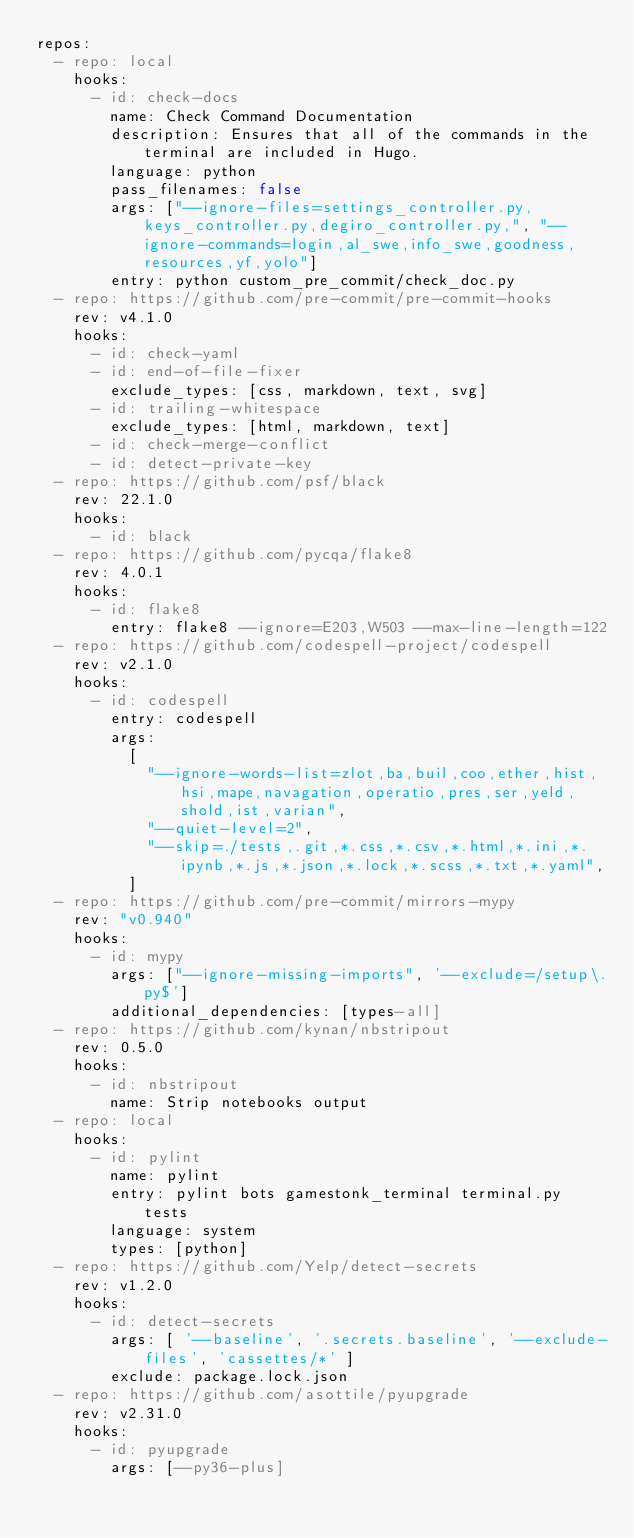<code> <loc_0><loc_0><loc_500><loc_500><_YAML_>repos:
  - repo: local
    hooks:
      - id: check-docs
        name: Check Command Documentation
        description: Ensures that all of the commands in the terminal are included in Hugo.
        language: python
        pass_filenames: false
        args: ["--ignore-files=settings_controller.py,keys_controller.py,degiro_controller.py,", "--ignore-commands=login,al_swe,info_swe,goodness,resources,yf,yolo"]
        entry: python custom_pre_commit/check_doc.py
  - repo: https://github.com/pre-commit/pre-commit-hooks
    rev: v4.1.0
    hooks:
      - id: check-yaml
      - id: end-of-file-fixer
        exclude_types: [css, markdown, text, svg]
      - id: trailing-whitespace
        exclude_types: [html, markdown, text]
      - id: check-merge-conflict
      - id: detect-private-key
  - repo: https://github.com/psf/black
    rev: 22.1.0
    hooks:
      - id: black
  - repo: https://github.com/pycqa/flake8
    rev: 4.0.1
    hooks:
      - id: flake8
        entry: flake8 --ignore=E203,W503 --max-line-length=122
  - repo: https://github.com/codespell-project/codespell
    rev: v2.1.0
    hooks:
      - id: codespell
        entry: codespell
        args:
          [
            "--ignore-words-list=zlot,ba,buil,coo,ether,hist,hsi,mape,navagation,operatio,pres,ser,yeld,shold,ist,varian",
            "--quiet-level=2",
            "--skip=./tests,.git,*.css,*.csv,*.html,*.ini,*.ipynb,*.js,*.json,*.lock,*.scss,*.txt,*.yaml",
          ]
  - repo: https://github.com/pre-commit/mirrors-mypy
    rev: "v0.940"
    hooks:
      - id: mypy
        args: ["--ignore-missing-imports", '--exclude=/setup\.py$']
        additional_dependencies: [types-all]
  - repo: https://github.com/kynan/nbstripout
    rev: 0.5.0
    hooks:
      - id: nbstripout
        name: Strip notebooks output
  - repo: local
    hooks:
      - id: pylint
        name: pylint
        entry: pylint bots gamestonk_terminal terminal.py tests
        language: system
        types: [python]
  - repo: https://github.com/Yelp/detect-secrets
    rev: v1.2.0
    hooks:
      - id: detect-secrets
        args: [ '--baseline', '.secrets.baseline', '--exclude-files', 'cassettes/*' ]
        exclude: package.lock.json
  - repo: https://github.com/asottile/pyupgrade
    rev: v2.31.0
    hooks:
      - id: pyupgrade
        args: [--py36-plus]
</code> 